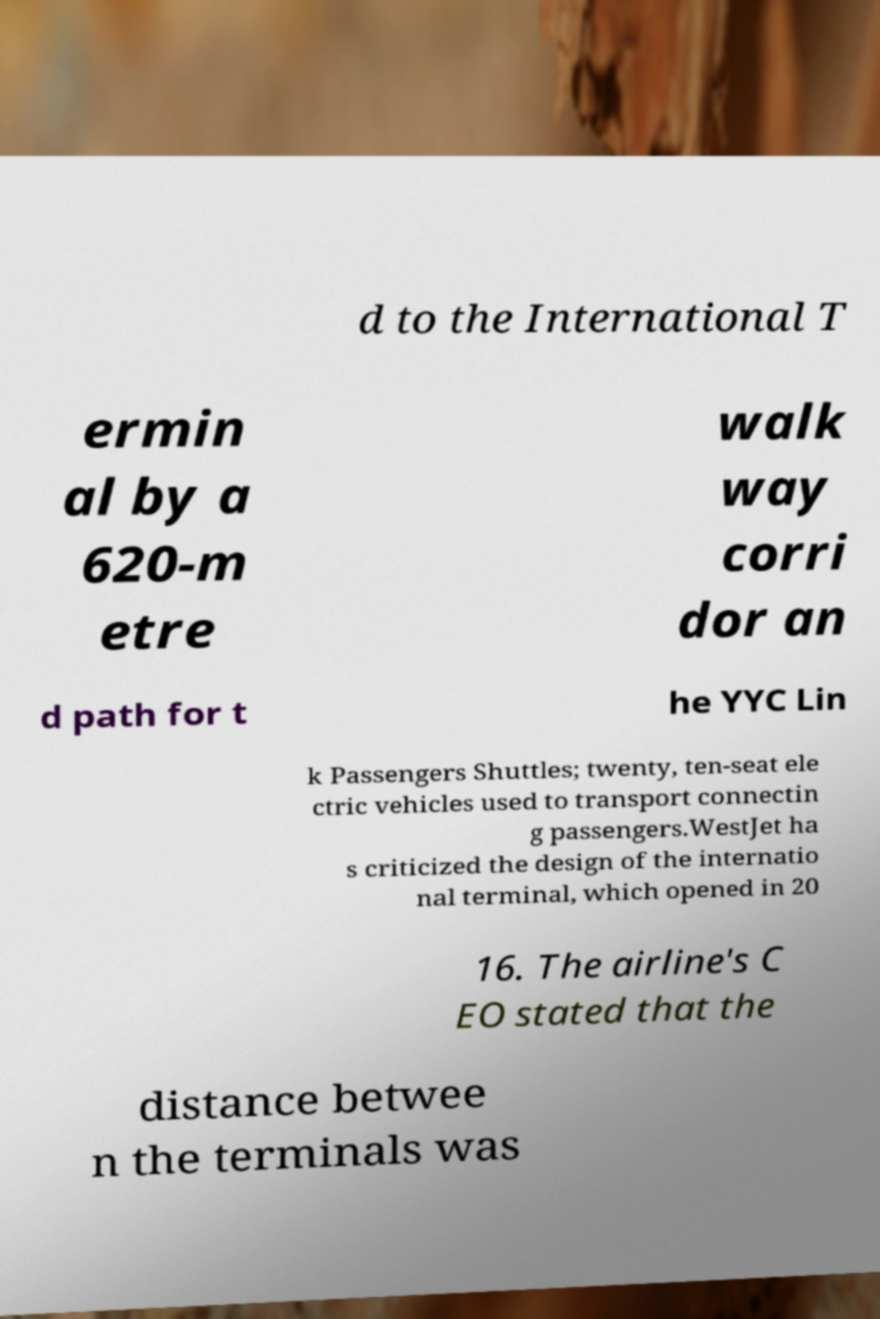What messages or text are displayed in this image? I need them in a readable, typed format. d to the International T ermin al by a 620-m etre walk way corri dor an d path for t he YYC Lin k Passengers Shuttles; twenty, ten-seat ele ctric vehicles used to transport connectin g passengers.WestJet ha s criticized the design of the internatio nal terminal, which opened in 20 16. The airline's C EO stated that the distance betwee n the terminals was 